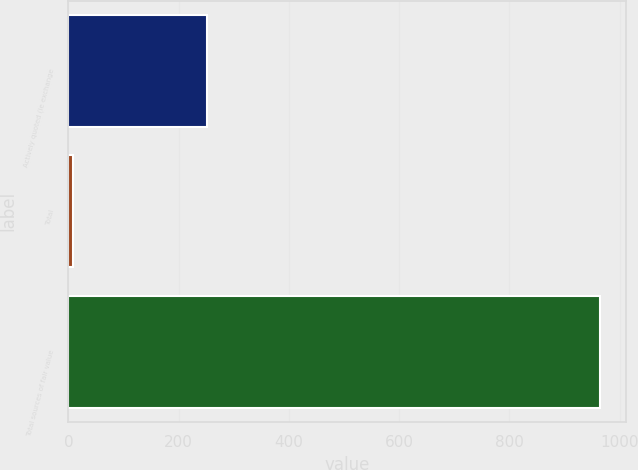Convert chart. <chart><loc_0><loc_0><loc_500><loc_500><bar_chart><fcel>Actively quoted (ie exchange<fcel>Total<fcel>Total sources of fair value<nl><fcel>251<fcel>8<fcel>964<nl></chart> 